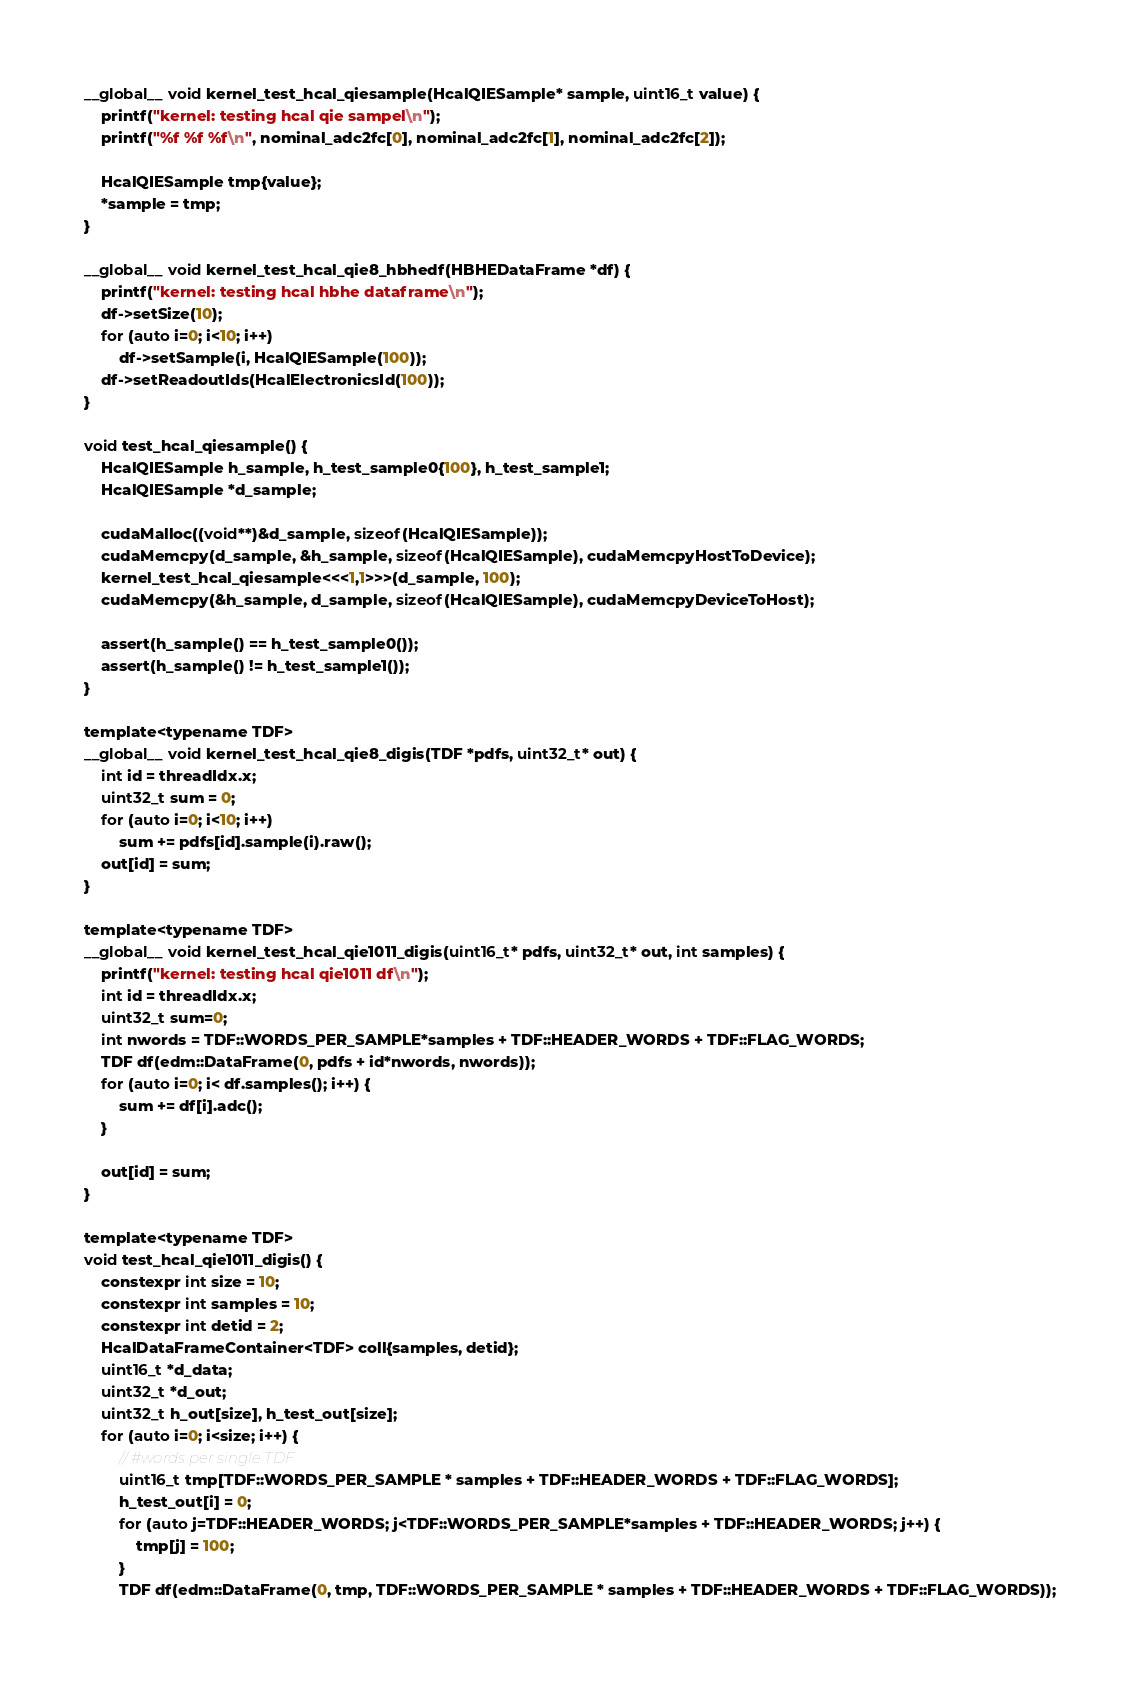Convert code to text. <code><loc_0><loc_0><loc_500><loc_500><_Cuda_>
__global__ void kernel_test_hcal_qiesample(HcalQIESample* sample, uint16_t value) {
    printf("kernel: testing hcal qie sampel\n");
    printf("%f %f %f\n", nominal_adc2fc[0], nominal_adc2fc[1], nominal_adc2fc[2]);

    HcalQIESample tmp{value};
    *sample = tmp;
}

__global__ void kernel_test_hcal_qie8_hbhedf(HBHEDataFrame *df) {
    printf("kernel: testing hcal hbhe dataframe\n");
    df->setSize(10);
    for (auto i=0; i<10; i++)
        df->setSample(i, HcalQIESample(100));
    df->setReadoutIds(HcalElectronicsId(100));
}

void test_hcal_qiesample() {
    HcalQIESample h_sample, h_test_sample0{100}, h_test_sample1;
    HcalQIESample *d_sample;

    cudaMalloc((void**)&d_sample, sizeof(HcalQIESample));
    cudaMemcpy(d_sample, &h_sample, sizeof(HcalQIESample), cudaMemcpyHostToDevice);
    kernel_test_hcal_qiesample<<<1,1>>>(d_sample, 100);
    cudaMemcpy(&h_sample, d_sample, sizeof(HcalQIESample), cudaMemcpyDeviceToHost);

    assert(h_sample() == h_test_sample0());
    assert(h_sample() != h_test_sample1());
}

template<typename TDF>
__global__ void kernel_test_hcal_qie8_digis(TDF *pdfs, uint32_t* out) {
    int id = threadIdx.x;
    uint32_t sum = 0;
    for (auto i=0; i<10; i++)
        sum += pdfs[id].sample(i).raw();
    out[id] = sum;
}

template<typename TDF>
__global__ void kernel_test_hcal_qie1011_digis(uint16_t* pdfs, uint32_t* out, int samples) {
    printf("kernel: testing hcal qie1011 df\n");
    int id = threadIdx.x;
    uint32_t sum=0;
    int nwords = TDF::WORDS_PER_SAMPLE*samples + TDF::HEADER_WORDS + TDF::FLAG_WORDS;
    TDF df(edm::DataFrame(0, pdfs + id*nwords, nwords));
    for (auto i=0; i< df.samples(); i++) {
        sum += df[i].adc();
    }

    out[id] = sum;
}

template<typename TDF>
void test_hcal_qie1011_digis() {
    constexpr int size = 10;
    constexpr int samples = 10;
    constexpr int detid = 2;
    HcalDataFrameContainer<TDF> coll{samples, detid};
    uint16_t *d_data;
    uint32_t *d_out;
    uint32_t h_out[size], h_test_out[size];
    for (auto i=0; i<size; i++) {
        // #words per single TDF
        uint16_t tmp[TDF::WORDS_PER_SAMPLE * samples + TDF::HEADER_WORDS + TDF::FLAG_WORDS];
        h_test_out[i] = 0;
        for (auto j=TDF::HEADER_WORDS; j<TDF::WORDS_PER_SAMPLE*samples + TDF::HEADER_WORDS; j++) {
            tmp[j] = 100;
        }
        TDF df(edm::DataFrame(0, tmp, TDF::WORDS_PER_SAMPLE * samples + TDF::HEADER_WORDS + TDF::FLAG_WORDS));</code> 